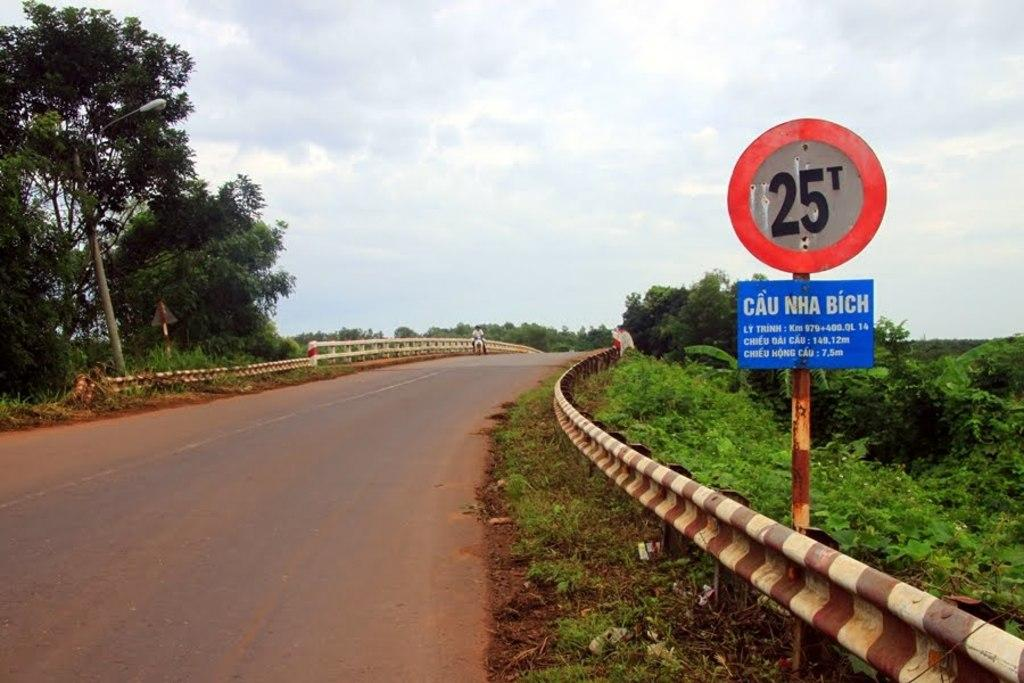<image>
Give a short and clear explanation of the subsequent image. A sign of the side of the road says 25 T. 